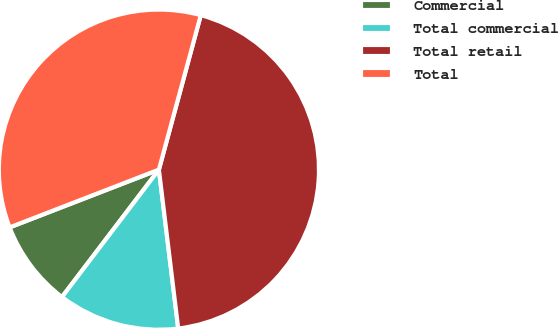<chart> <loc_0><loc_0><loc_500><loc_500><pie_chart><fcel>Commercial<fcel>Total commercial<fcel>Total retail<fcel>Total<nl><fcel>8.77%<fcel>12.28%<fcel>43.86%<fcel>35.09%<nl></chart> 